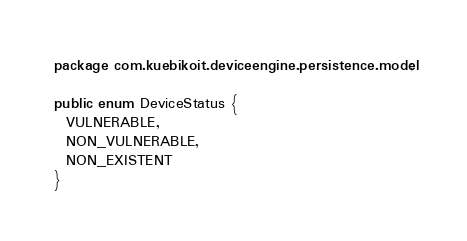<code> <loc_0><loc_0><loc_500><loc_500><_Java_>package com.kuebikoit.deviceengine.persistence.model;

public enum DeviceStatus {
  VULNERABLE,
  NON_VULNERABLE,
  NON_EXISTENT
}
</code> 